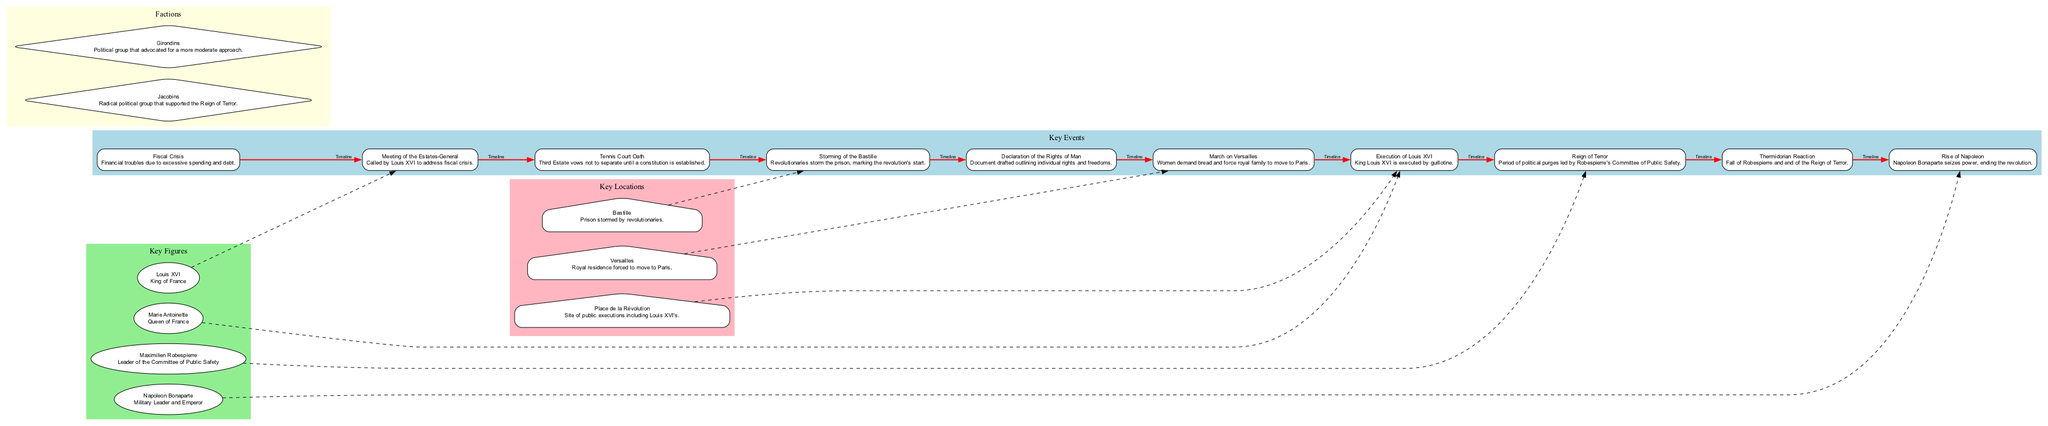What event marked the start of the French Revolution? The diagram indicates that the "Storming of the Bastille" is the first major event labeled as marking the start of the revolution.
Answer: Storming of the Bastille How many key figures are represented in the diagram? By counting the nodes labeled as figures in the diagram, I see there are four key figures.
Answer: 4 Which faction supported the Reign of Terror? The description of the "Jacobins" faction in the diagram directly states that they supported the Reign of Terror.
Answer: Jacobins What was the outcome of the Thermidorian Reaction? The diagram connects the "Thermidorian Reaction" event to the fall of "Robespierre," which signifies the end of the Reign of Terror.
Answer: Fall of Robespierre Which location is associated with the execution of Louis XVI? The diagram clearly links the "Place de la Révolution" to the event of Louis XVI's execution, indicating this location is key for that event.
Answer: Place de la Révolution What event preceded the March on Versailles? By looking at the timeline order in the diagram, I can follow the events and see that the "Declaration of the Rights of Man" precedes the "March on Versailles."
Answer: Declaration of the Rights of Man Who was the leader of the Committee of Public Safety? The diagram attributes the role of the leader of the Committee of Public Safety to Maximilien Robespierre, as indicated next to his figure.
Answer: Maximilien Robespierre What did the Third Estate pledge during the Tennis Court Oath? The description associated with the "Tennis Court Oath" mentions that the Third Estate vowed not to separate until a constitution was established.
Answer: Constitution Which event resulted in the royal family moving to Paris? The "March on Versailles" event in the diagram directly states that women demanded bread and forced the royal family to move to Paris.
Answer: March on Versailles 